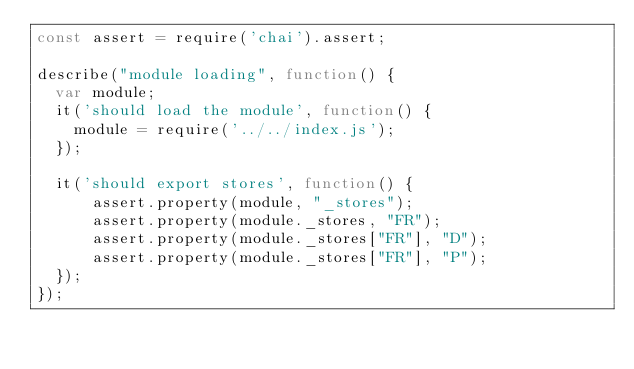Convert code to text. <code><loc_0><loc_0><loc_500><loc_500><_JavaScript_>const assert = require('chai').assert;

describe("module loading", function() {
  var module;
  it('should load the module', function() {
    module = require('../../index.js');
  });

  it('should export stores', function() {
      assert.property(module, "_stores");
      assert.property(module._stores, "FR");
      assert.property(module._stores["FR"], "D");
      assert.property(module._stores["FR"], "P");
  });
});
</code> 